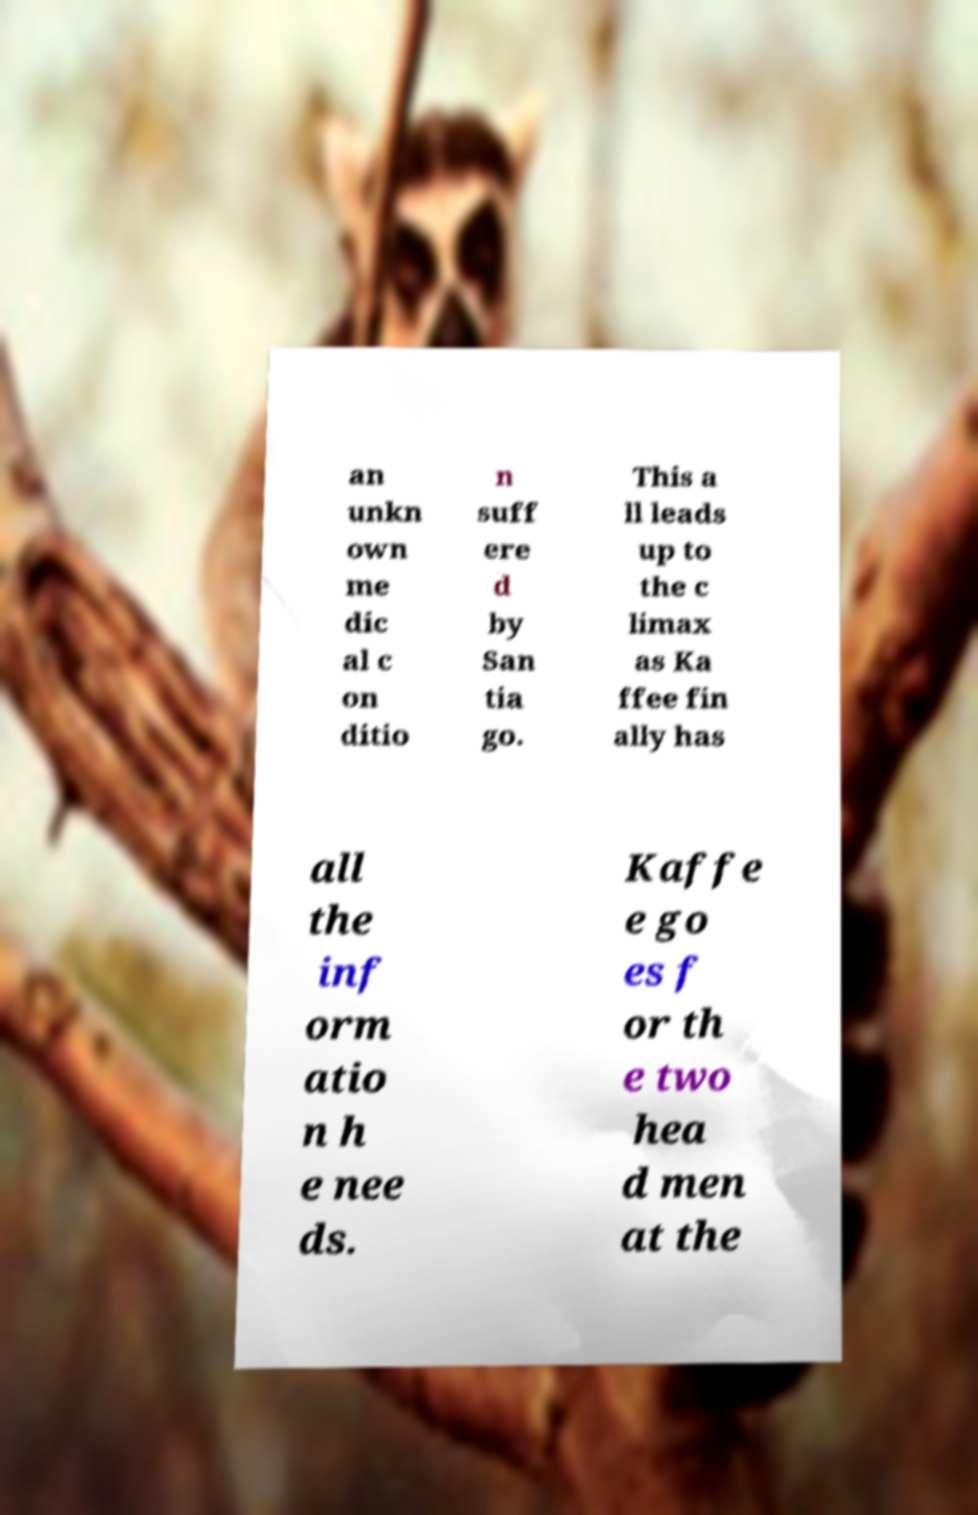Could you assist in decoding the text presented in this image and type it out clearly? an unkn own me dic al c on ditio n suff ere d by San tia go. This a ll leads up to the c limax as Ka ffee fin ally has all the inf orm atio n h e nee ds. Kaffe e go es f or th e two hea d men at the 